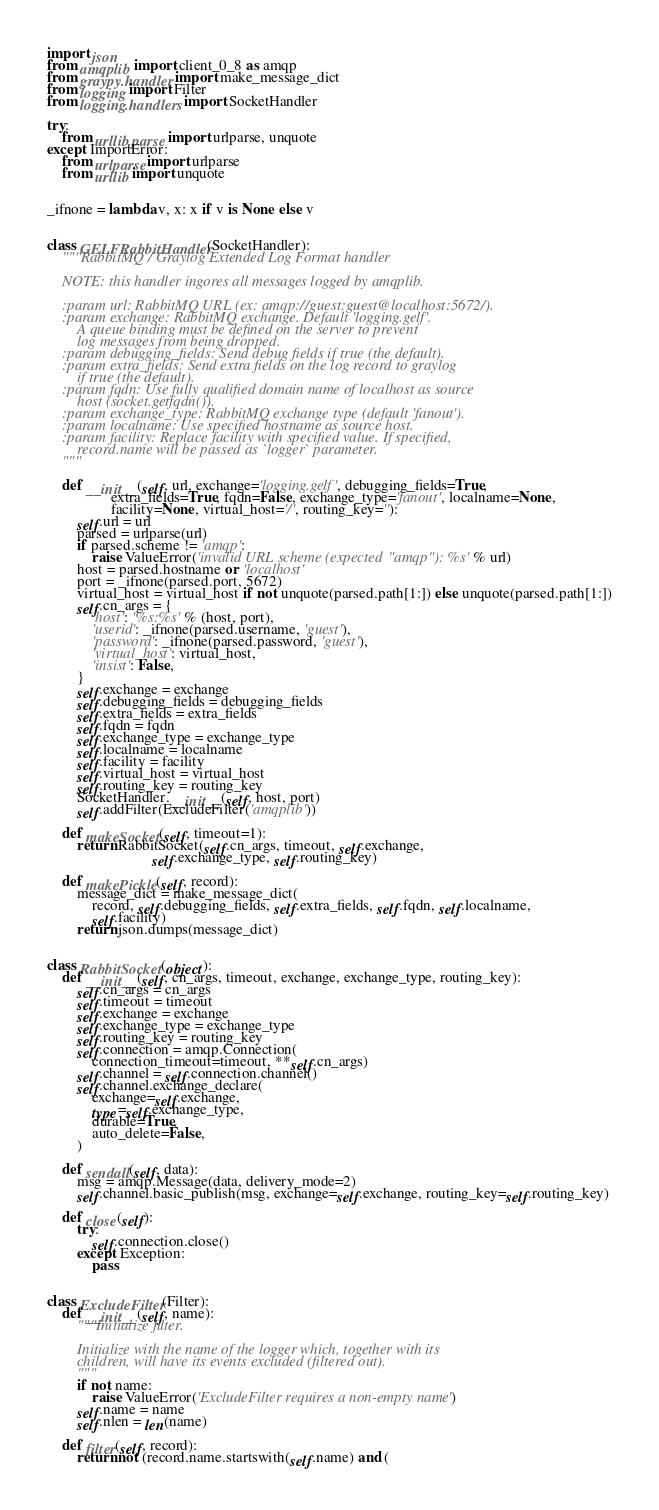Convert code to text. <code><loc_0><loc_0><loc_500><loc_500><_Python_>import json
from amqplib import client_0_8 as amqp
from graypy.handler import make_message_dict
from logging import Filter
from logging.handlers import SocketHandler

try:
    from urllib.parse import urlparse, unquote
except ImportError:
    from urlparse import urlparse
    from urllib import unquote


_ifnone = lambda v, x: x if v is None else v


class GELFRabbitHandler(SocketHandler):
    """RabbitMQ / Graylog Extended Log Format handler

    NOTE: this handler ingores all messages logged by amqplib.

    :param url: RabbitMQ URL (ex: amqp://guest:guest@localhost:5672/).
    :param exchange: RabbitMQ exchange. Default 'logging.gelf'.
        A queue binding must be defined on the server to prevent
        log messages from being dropped.
    :param debugging_fields: Send debug fields if true (the default).
    :param extra_fields: Send extra fields on the log record to graylog
        if true (the default).
    :param fqdn: Use fully qualified domain name of localhost as source 
        host (socket.getfqdn()).
    :param exchange_type: RabbitMQ exchange type (default 'fanout').
    :param localname: Use specified hostname as source host.
    :param facility: Replace facility with specified value. If specified,
        record.name will be passed as `logger` parameter.
    """

    def __init__(self, url, exchange='logging.gelf', debugging_fields=True,
                 extra_fields=True, fqdn=False, exchange_type='fanout', localname=None,
                 facility=None, virtual_host='/', routing_key=''):
        self.url = url
        parsed = urlparse(url)
        if parsed.scheme != 'amqp':
            raise ValueError('invalid URL scheme (expected "amqp"): %s' % url)
        host = parsed.hostname or 'localhost'
        port = _ifnone(parsed.port, 5672)
        virtual_host = virtual_host if not unquote(parsed.path[1:]) else unquote(parsed.path[1:])
        self.cn_args = {
            'host': '%s:%s' % (host, port),
            'userid': _ifnone(parsed.username, 'guest'),
            'password': _ifnone(parsed.password, 'guest'),
            'virtual_host': virtual_host,
            'insist': False,
        }
        self.exchange = exchange
        self.debugging_fields = debugging_fields
        self.extra_fields = extra_fields
        self.fqdn = fqdn
        self.exchange_type = exchange_type
        self.localname = localname
        self.facility = facility
        self.virtual_host = virtual_host
        self.routing_key = routing_key
        SocketHandler.__init__(self, host, port)
        self.addFilter(ExcludeFilter('amqplib'))

    def makeSocket(self, timeout=1):
        return RabbitSocket(self.cn_args, timeout, self.exchange,
                            self.exchange_type, self.routing_key)

    def makePickle(self, record):
        message_dict = make_message_dict(
            record, self.debugging_fields, self.extra_fields, self.fqdn, self.localname,
            self.facility)
        return json.dumps(message_dict)


class RabbitSocket(object):
    def __init__(self, cn_args, timeout, exchange, exchange_type, routing_key):
        self.cn_args = cn_args
        self.timeout = timeout
        self.exchange = exchange
        self.exchange_type = exchange_type
        self.routing_key = routing_key
        self.connection = amqp.Connection(
            connection_timeout=timeout, **self.cn_args)
        self.channel = self.connection.channel()
        self.channel.exchange_declare(
            exchange=self.exchange,
            type=self.exchange_type,
            durable=True,
            auto_delete=False,
        )

    def sendall(self, data):
        msg = amqp.Message(data, delivery_mode=2)
        self.channel.basic_publish(msg, exchange=self.exchange, routing_key=self.routing_key)

    def close(self):
        try:
            self.connection.close()
        except Exception:
            pass


class ExcludeFilter(Filter):
    def __init__(self, name):
        """Initialize filter.

        Initialize with the name of the logger which, together with its
        children, will have its events excluded (filtered out).
        """
        if not name:
            raise ValueError('ExcludeFilter requires a non-empty name')
        self.name = name
        self.nlen = len(name)

    def filter(self, record):
        return not (record.name.startswith(self.name) and (</code> 